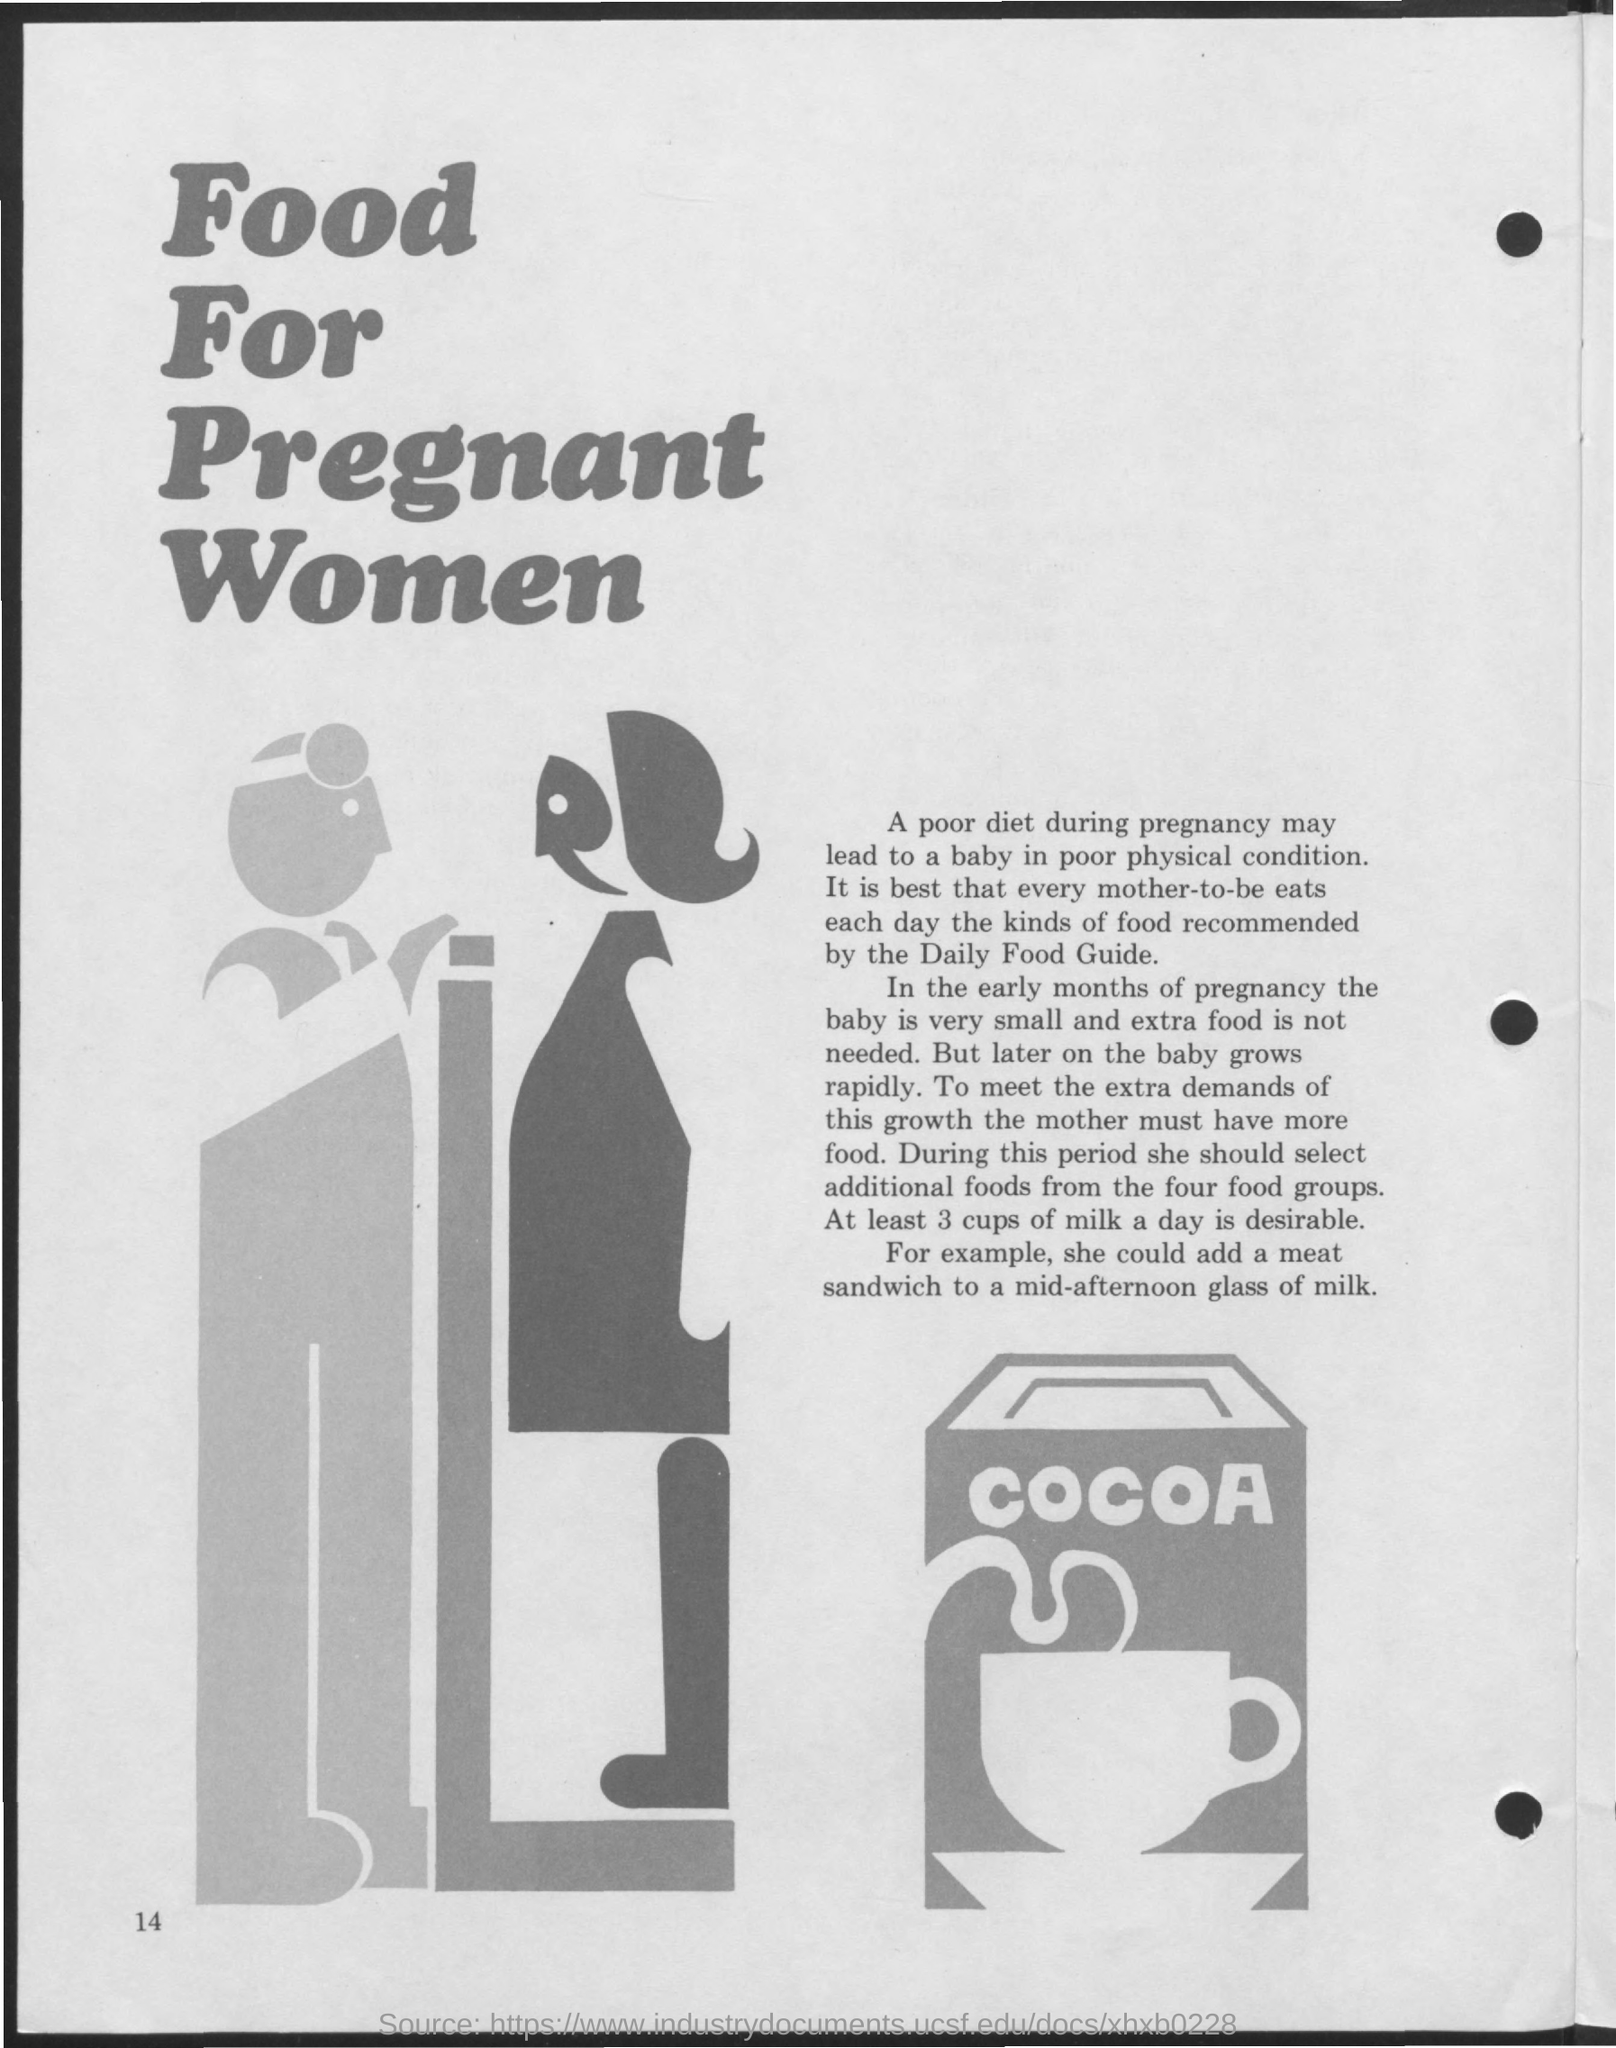What is the Title of the document?
Make the answer very short. Food for Pregnant Women. How much milk is desirable a day?
Your answer should be compact. At least 3 cups. 